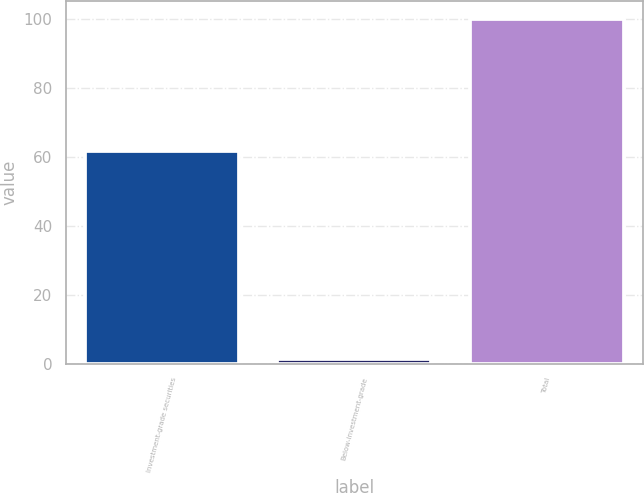<chart> <loc_0><loc_0><loc_500><loc_500><bar_chart><fcel>Investment-grade securities<fcel>Below-investment-grade<fcel>Total<nl><fcel>61.7<fcel>1.5<fcel>100<nl></chart> 